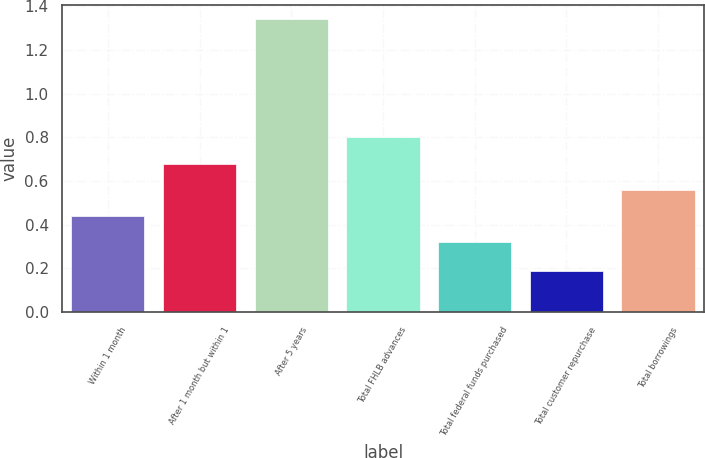Convert chart to OTSL. <chart><loc_0><loc_0><loc_500><loc_500><bar_chart><fcel>Within 1 month<fcel>After 1 month but within 1<fcel>After 5 years<fcel>Total FHLB advances<fcel>Total federal funds purchased<fcel>Total customer repurchase<fcel>Total borrowings<nl><fcel>0.44<fcel>0.68<fcel>1.34<fcel>0.8<fcel>0.32<fcel>0.19<fcel>0.56<nl></chart> 